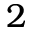<formula> <loc_0><loc_0><loc_500><loc_500>2</formula> 